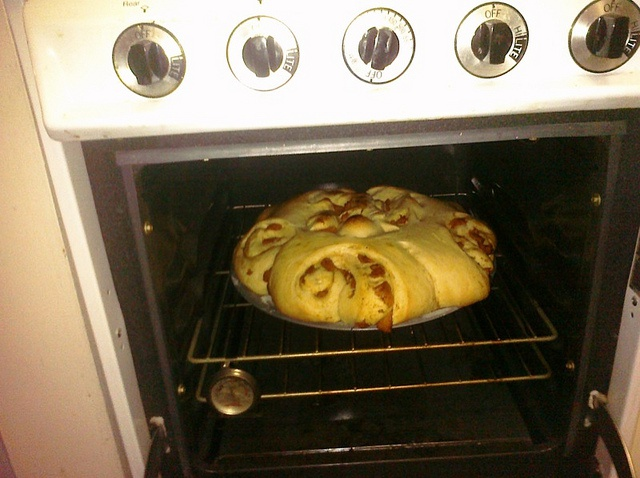Describe the objects in this image and their specific colors. I can see oven in black, white, tan, and maroon tones and pizza in tan, olive, and orange tones in this image. 